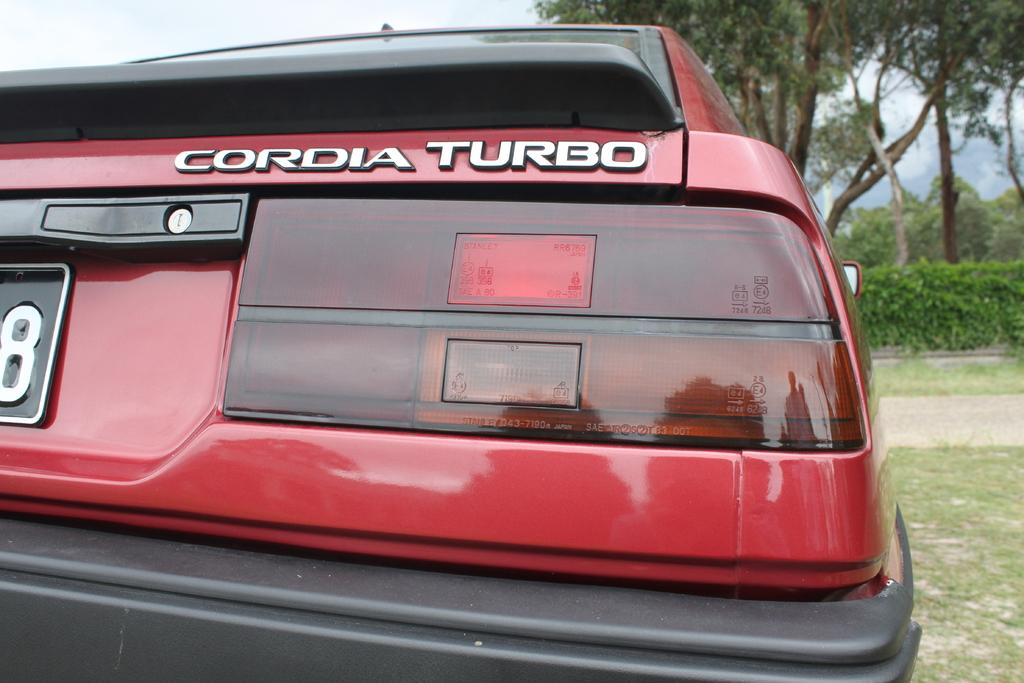<image>
Write a terse but informative summary of the picture. the back of a red CORDIA TURBO car parked and not on the road. 